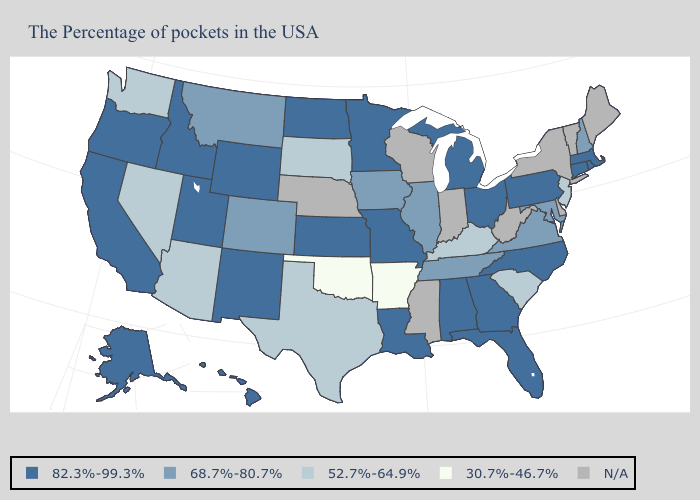What is the highest value in states that border Virginia?
Short answer required. 82.3%-99.3%. Which states hav the highest value in the South?
Short answer required. North Carolina, Florida, Georgia, Alabama, Louisiana. Name the states that have a value in the range 30.7%-46.7%?
Short answer required. Arkansas, Oklahoma. Name the states that have a value in the range 52.7%-64.9%?
Keep it brief. New Jersey, South Carolina, Kentucky, Texas, South Dakota, Arizona, Nevada, Washington. Name the states that have a value in the range N/A?
Answer briefly. Maine, Vermont, New York, Delaware, West Virginia, Indiana, Wisconsin, Mississippi, Nebraska. Does South Dakota have the lowest value in the USA?
Concise answer only. No. Does Oklahoma have the highest value in the USA?
Give a very brief answer. No. What is the value of Massachusetts?
Be succinct. 82.3%-99.3%. Which states have the highest value in the USA?
Keep it brief. Massachusetts, Rhode Island, Connecticut, Pennsylvania, North Carolina, Ohio, Florida, Georgia, Michigan, Alabama, Louisiana, Missouri, Minnesota, Kansas, North Dakota, Wyoming, New Mexico, Utah, Idaho, California, Oregon, Alaska, Hawaii. Name the states that have a value in the range 30.7%-46.7%?
Quick response, please. Arkansas, Oklahoma. Does New Mexico have the highest value in the USA?
Concise answer only. Yes. Does Ohio have the highest value in the MidWest?
Concise answer only. Yes. What is the value of Rhode Island?
Keep it brief. 82.3%-99.3%. Does New Jersey have the lowest value in the Northeast?
Answer briefly. Yes. Name the states that have a value in the range N/A?
Answer briefly. Maine, Vermont, New York, Delaware, West Virginia, Indiana, Wisconsin, Mississippi, Nebraska. 